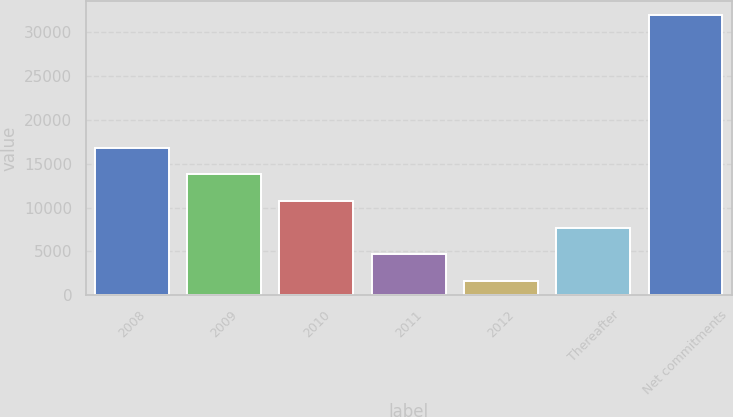Convert chart. <chart><loc_0><loc_0><loc_500><loc_500><bar_chart><fcel>2008<fcel>2009<fcel>2010<fcel>2011<fcel>2012<fcel>Thereafter<fcel>Net commitments<nl><fcel>16817<fcel>13785.6<fcel>10754.2<fcel>4691.4<fcel>1660<fcel>7722.8<fcel>31974<nl></chart> 